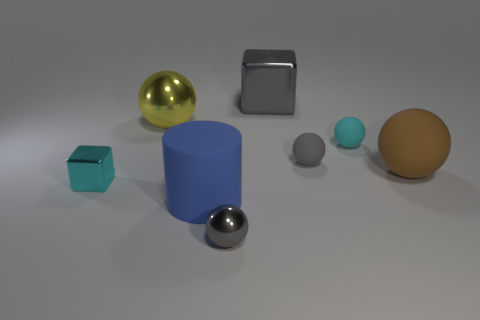Subtract all tiny gray metallic spheres. How many spheres are left? 4 Add 2 large cylinders. How many objects exist? 10 Subtract 0 yellow cubes. How many objects are left? 8 Subtract all balls. How many objects are left? 3 Subtract 1 cylinders. How many cylinders are left? 0 Subtract all red blocks. Subtract all cyan cylinders. How many blocks are left? 2 Subtract all red cylinders. How many yellow blocks are left? 0 Subtract all cyan rubber balls. Subtract all cyan blocks. How many objects are left? 6 Add 6 blue objects. How many blue objects are left? 7 Add 2 big purple metallic cylinders. How many big purple metallic cylinders exist? 2 